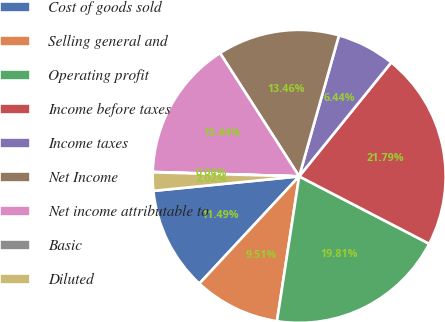<chart> <loc_0><loc_0><loc_500><loc_500><pie_chart><fcel>Cost of goods sold<fcel>Selling general and<fcel>Operating profit<fcel>Income before taxes<fcel>Income taxes<fcel>Net Income<fcel>Net income attributable to<fcel>Basic<fcel>Diluted<nl><fcel>11.49%<fcel>9.51%<fcel>19.81%<fcel>21.79%<fcel>6.44%<fcel>13.46%<fcel>15.44%<fcel>0.04%<fcel>2.02%<nl></chart> 